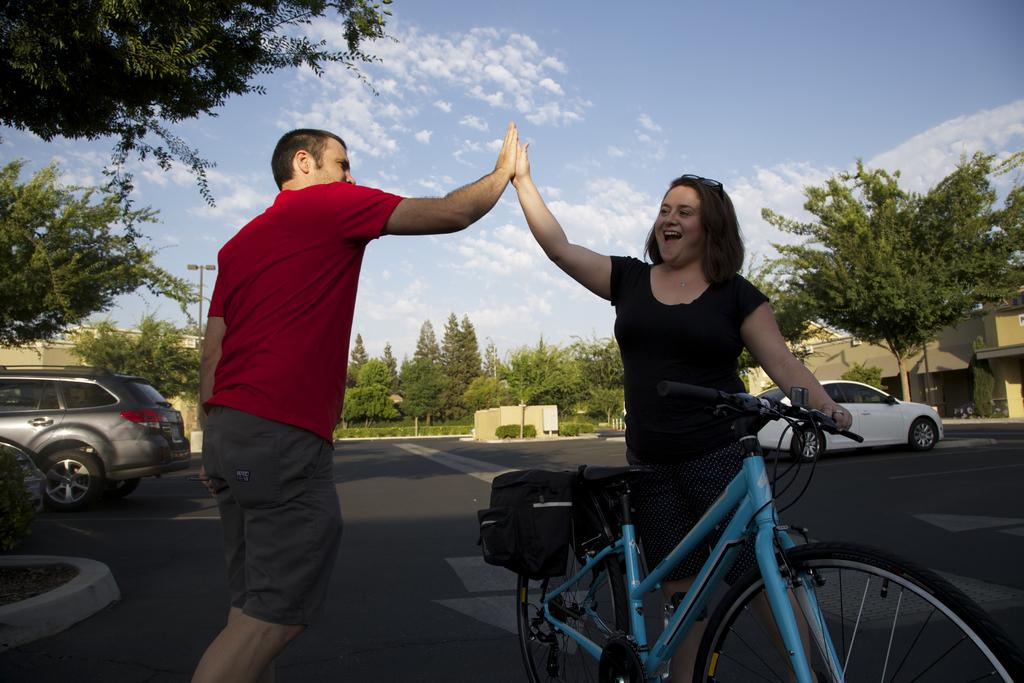How many people are in the image? There are two persons in the image. What is the woman holding in the image? The woman is holding a cycle. What can be seen on the road in the image? There are vehicles on the road in the image. What is visible in the background of the image? There is a building, trees, and the sky visible in the background of the image. What is the woman's favorite hobby, and is it mentioned in the image? The image does not provide information about the woman's hobbies, so it cannot be determined from the image. 